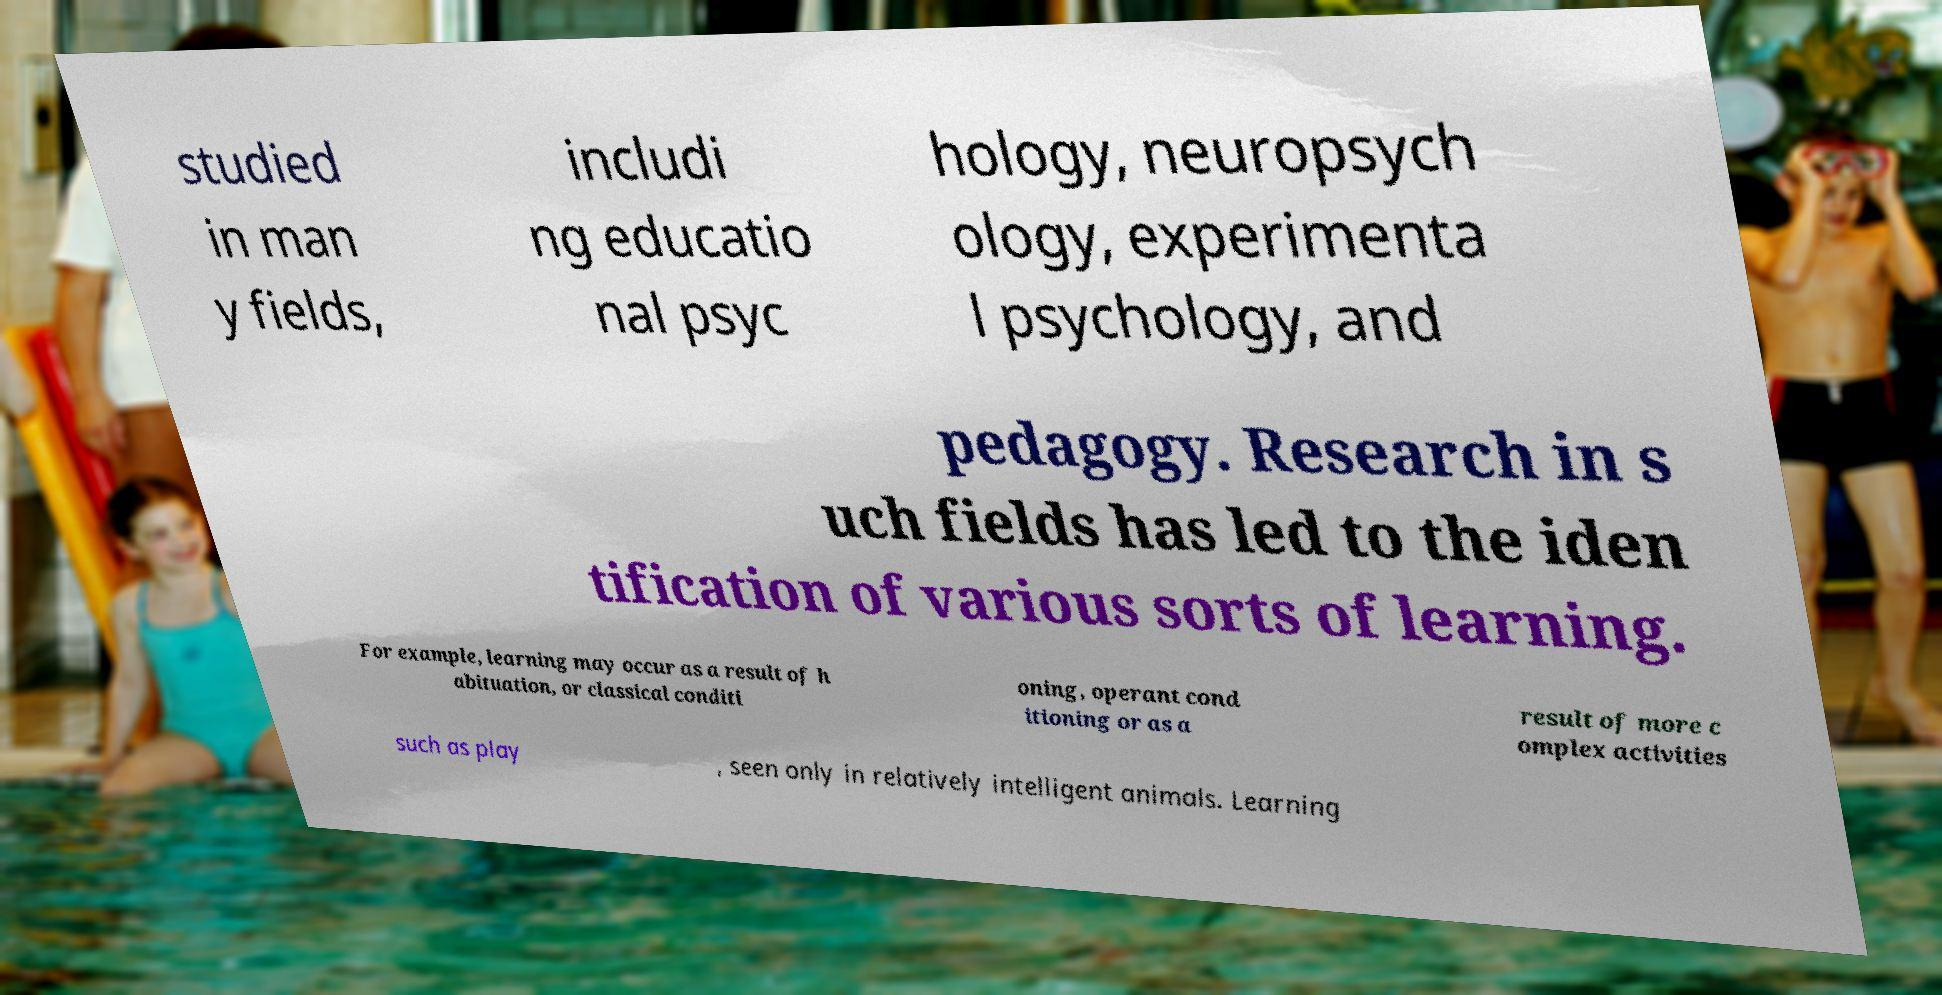There's text embedded in this image that I need extracted. Can you transcribe it verbatim? studied in man y fields, includi ng educatio nal psyc hology, neuropsych ology, experimenta l psychology, and pedagogy. Research in s uch fields has led to the iden tification of various sorts of learning. For example, learning may occur as a result of h abituation, or classical conditi oning, operant cond itioning or as a result of more c omplex activities such as play , seen only in relatively intelligent animals. Learning 